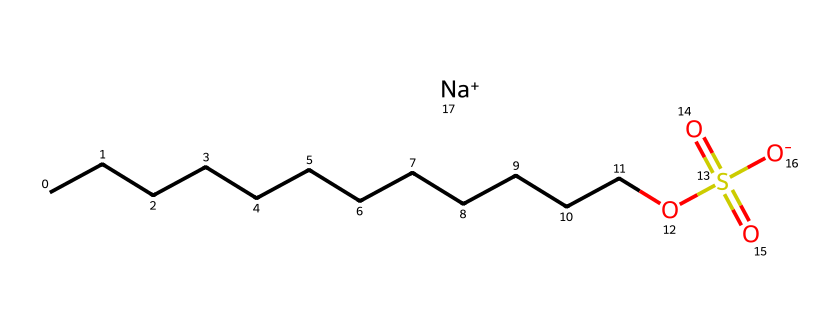What is the main functional group present in this surfactant? The SMILES representation indicates the presence of a sulfonate group (OS(=O)(=O)[O-]) in the structure, which is the main functional group that characterizes this surfactant.
Answer: sulfonate How many carbon atoms are there in the hydrophobic tail of this surfactant? By analyzing the hydrocarbon chain (CCCCCCCCCCCC), we count 12 carbon atoms in the tail, which is typical for surfactants aiming to minimize surface tension.
Answer: 12 What is the charge of the surfactant at physiological pH? The presence of the sulfonate group, which is negatively charged (OS(=O)(=O)[O-]), indicates that the surfactant carries a negative charge at physiological pH, making it an anionic surfactant.
Answer: negative What type of surfactant does this structure represent? The presence of a long hydrophobic tail (12 carbons) and a negatively charged sulfonate group classifies this molecule as an anionic surfactant.
Answer: anionic How many oxygen atoms are connected to the sulfur in the functional group? In the sulfonate group (OS(=O)(=O)[O-]), there are three oxygen atoms connected to the sulfur, as indicated by the sulfonyl structure.
Answer: 3 